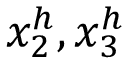<formula> <loc_0><loc_0><loc_500><loc_500>x _ { 2 } ^ { h } , x _ { 3 } ^ { h }</formula> 